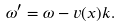Convert formula to latex. <formula><loc_0><loc_0><loc_500><loc_500>\omega ^ { \prime } = \omega - v ( x ) k .</formula> 